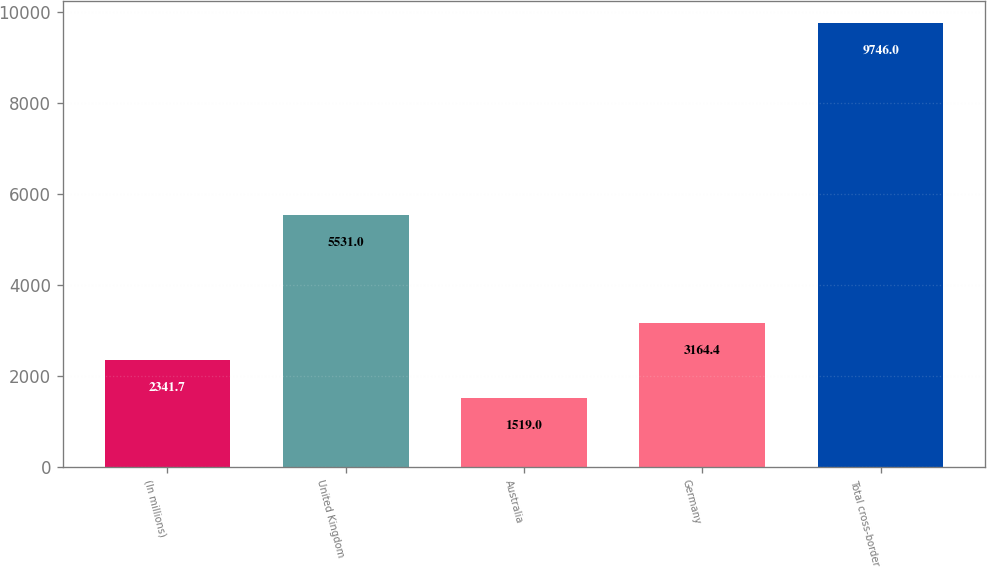<chart> <loc_0><loc_0><loc_500><loc_500><bar_chart><fcel>(In millions)<fcel>United Kingdom<fcel>Australia<fcel>Germany<fcel>Total cross-border<nl><fcel>2341.7<fcel>5531<fcel>1519<fcel>3164.4<fcel>9746<nl></chart> 